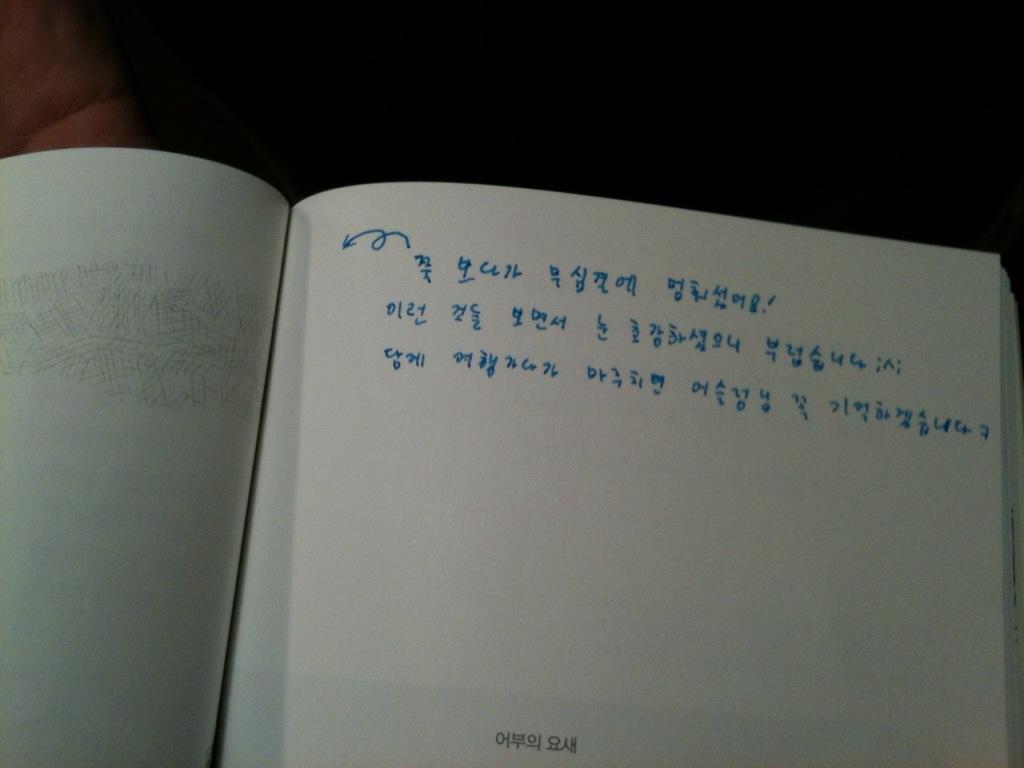What is the last number written on the page?
Offer a very short reply. 7. 